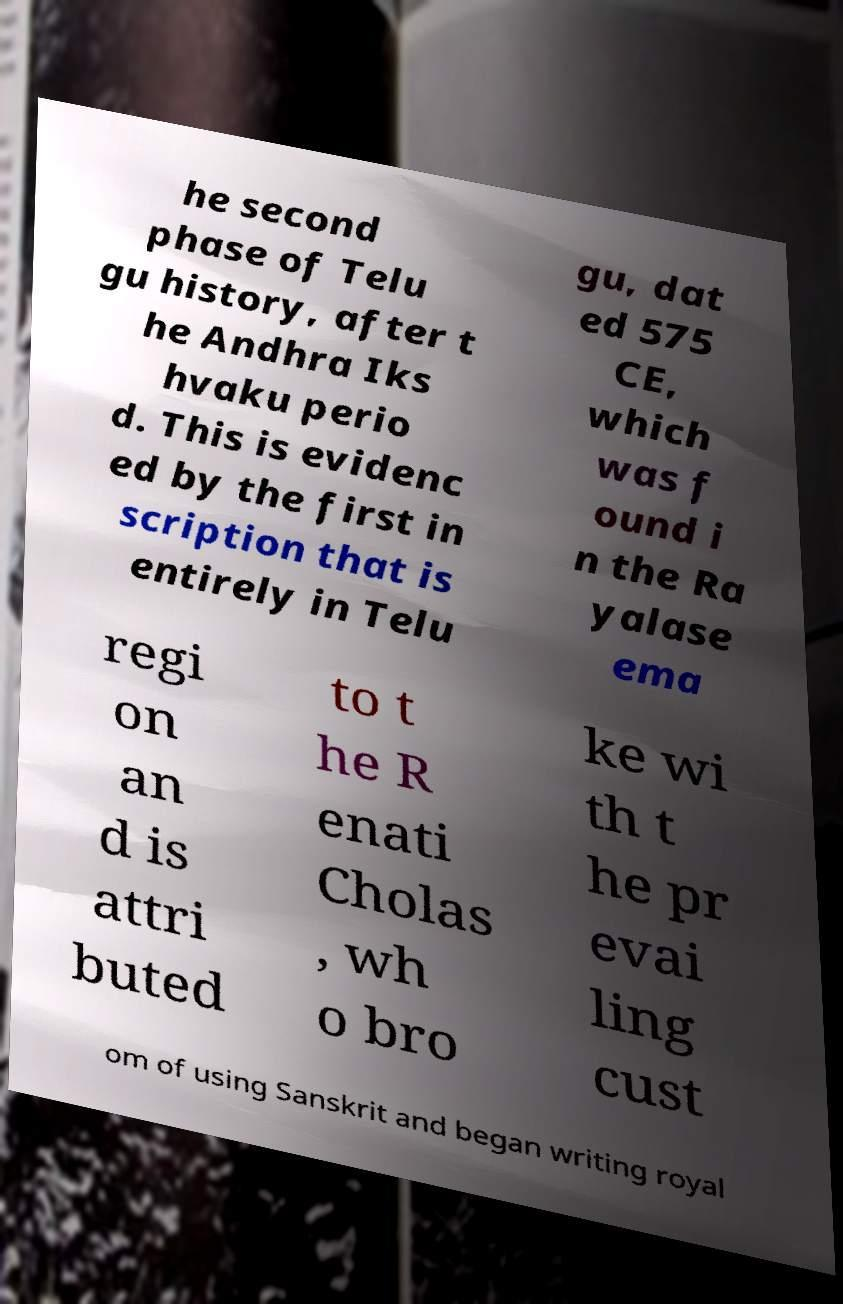Could you extract and type out the text from this image? he second phase of Telu gu history, after t he Andhra Iks hvaku perio d. This is evidenc ed by the first in scription that is entirely in Telu gu, dat ed 575 CE, which was f ound i n the Ra yalase ema regi on an d is attri buted to t he R enati Cholas , wh o bro ke wi th t he pr evai ling cust om of using Sanskrit and began writing royal 